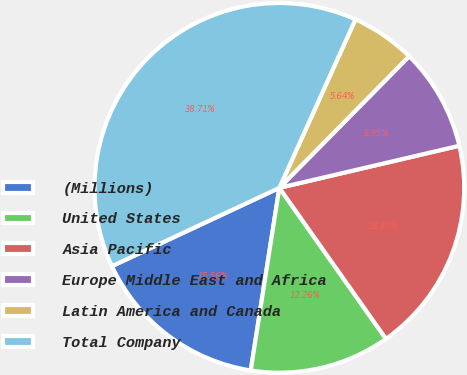Convert chart. <chart><loc_0><loc_0><loc_500><loc_500><pie_chart><fcel>(Millions)<fcel>United States<fcel>Asia Pacific<fcel>Europe Middle East and Africa<fcel>Latin America and Canada<fcel>Total Company<nl><fcel>15.56%<fcel>12.26%<fcel>18.87%<fcel>8.95%<fcel>5.64%<fcel>38.71%<nl></chart> 